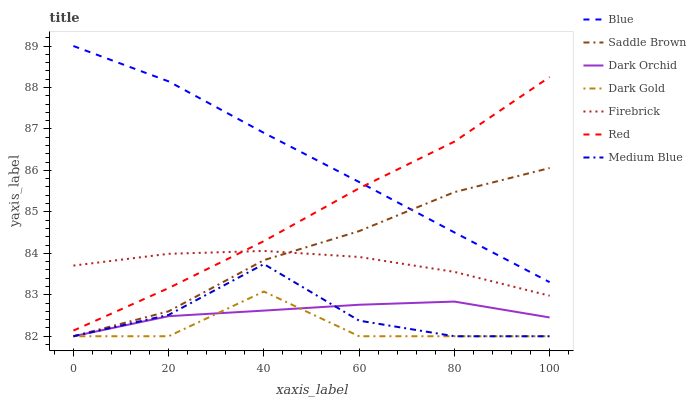Does Dark Gold have the minimum area under the curve?
Answer yes or no. Yes. Does Blue have the maximum area under the curve?
Answer yes or no. Yes. Does Firebrick have the minimum area under the curve?
Answer yes or no. No. Does Firebrick have the maximum area under the curve?
Answer yes or no. No. Is Blue the smoothest?
Answer yes or no. Yes. Is Medium Blue the roughest?
Answer yes or no. Yes. Is Dark Gold the smoothest?
Answer yes or no. No. Is Dark Gold the roughest?
Answer yes or no. No. Does Dark Gold have the lowest value?
Answer yes or no. Yes. Does Firebrick have the lowest value?
Answer yes or no. No. Does Blue have the highest value?
Answer yes or no. Yes. Does Dark Gold have the highest value?
Answer yes or no. No. Is Dark Gold less than Red?
Answer yes or no. Yes. Is Blue greater than Firebrick?
Answer yes or no. Yes. Does Dark Orchid intersect Saddle Brown?
Answer yes or no. Yes. Is Dark Orchid less than Saddle Brown?
Answer yes or no. No. Is Dark Orchid greater than Saddle Brown?
Answer yes or no. No. Does Dark Gold intersect Red?
Answer yes or no. No. 